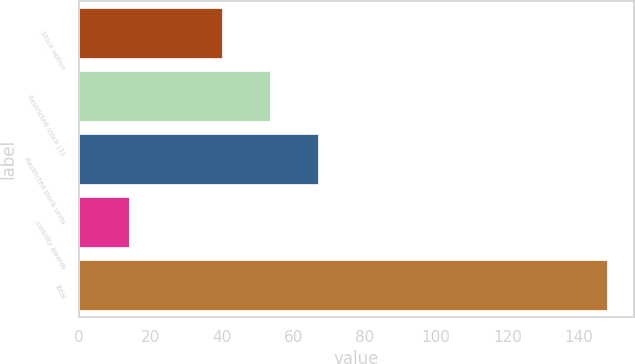Convert chart to OTSL. <chart><loc_0><loc_0><loc_500><loc_500><bar_chart><fcel>Stock option<fcel>Restricted stock (1)<fcel>Restricted stock units<fcel>Liability awards<fcel>Total<nl><fcel>40<fcel>53.4<fcel>66.8<fcel>14<fcel>148<nl></chart> 